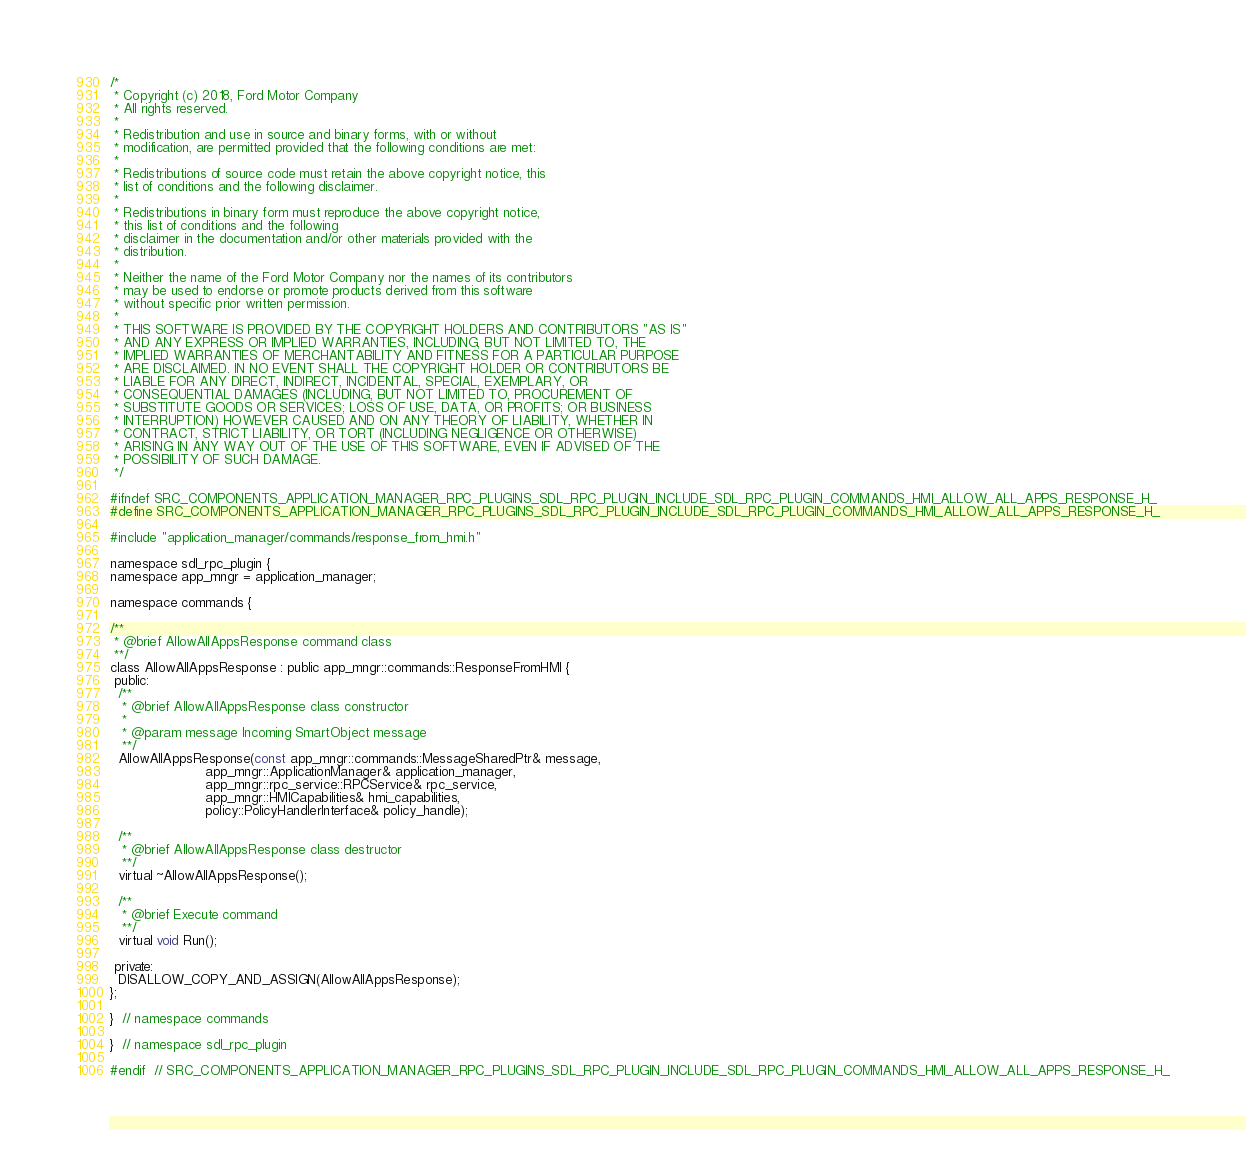<code> <loc_0><loc_0><loc_500><loc_500><_C_>/*
 * Copyright (c) 2018, Ford Motor Company
 * All rights reserved.
 *
 * Redistribution and use in source and binary forms, with or without
 * modification, are permitted provided that the following conditions are met:
 *
 * Redistributions of source code must retain the above copyright notice, this
 * list of conditions and the following disclaimer.
 *
 * Redistributions in binary form must reproduce the above copyright notice,
 * this list of conditions and the following
 * disclaimer in the documentation and/or other materials provided with the
 * distribution.
 *
 * Neither the name of the Ford Motor Company nor the names of its contributors
 * may be used to endorse or promote products derived from this software
 * without specific prior written permission.
 *
 * THIS SOFTWARE IS PROVIDED BY THE COPYRIGHT HOLDERS AND CONTRIBUTORS "AS IS"
 * AND ANY EXPRESS OR IMPLIED WARRANTIES, INCLUDING, BUT NOT LIMITED TO, THE
 * IMPLIED WARRANTIES OF MERCHANTABILITY AND FITNESS FOR A PARTICULAR PURPOSE
 * ARE DISCLAIMED. IN NO EVENT SHALL THE COPYRIGHT HOLDER OR CONTRIBUTORS BE
 * LIABLE FOR ANY DIRECT, INDIRECT, INCIDENTAL, SPECIAL, EXEMPLARY, OR
 * CONSEQUENTIAL DAMAGES (INCLUDING, BUT NOT LIMITED TO, PROCUREMENT OF
 * SUBSTITUTE GOODS OR SERVICES; LOSS OF USE, DATA, OR PROFITS; OR BUSINESS
 * INTERRUPTION) HOWEVER CAUSED AND ON ANY THEORY OF LIABILITY, WHETHER IN
 * CONTRACT, STRICT LIABILITY, OR TORT (INCLUDING NEGLIGENCE OR OTHERWISE)
 * ARISING IN ANY WAY OUT OF THE USE OF THIS SOFTWARE, EVEN IF ADVISED OF THE
 * POSSIBILITY OF SUCH DAMAGE.
 */

#ifndef SRC_COMPONENTS_APPLICATION_MANAGER_RPC_PLUGINS_SDL_RPC_PLUGIN_INCLUDE_SDL_RPC_PLUGIN_COMMANDS_HMI_ALLOW_ALL_APPS_RESPONSE_H_
#define SRC_COMPONENTS_APPLICATION_MANAGER_RPC_PLUGINS_SDL_RPC_PLUGIN_INCLUDE_SDL_RPC_PLUGIN_COMMANDS_HMI_ALLOW_ALL_APPS_RESPONSE_H_

#include "application_manager/commands/response_from_hmi.h"

namespace sdl_rpc_plugin {
namespace app_mngr = application_manager;

namespace commands {

/**
 * @brief AllowAllAppsResponse command class
 **/
class AllowAllAppsResponse : public app_mngr::commands::ResponseFromHMI {
 public:
  /**
   * @brief AllowAllAppsResponse class constructor
   *
   * @param message Incoming SmartObject message
   **/
  AllowAllAppsResponse(const app_mngr::commands::MessageSharedPtr& message,
                       app_mngr::ApplicationManager& application_manager,
                       app_mngr::rpc_service::RPCService& rpc_service,
                       app_mngr::HMICapabilities& hmi_capabilities,
                       policy::PolicyHandlerInterface& policy_handle);

  /**
   * @brief AllowAllAppsResponse class destructor
   **/
  virtual ~AllowAllAppsResponse();

  /**
   * @brief Execute command
   **/
  virtual void Run();

 private:
  DISALLOW_COPY_AND_ASSIGN(AllowAllAppsResponse);
};

}  // namespace commands

}  // namespace sdl_rpc_plugin

#endif  // SRC_COMPONENTS_APPLICATION_MANAGER_RPC_PLUGINS_SDL_RPC_PLUGIN_INCLUDE_SDL_RPC_PLUGIN_COMMANDS_HMI_ALLOW_ALL_APPS_RESPONSE_H_
</code> 